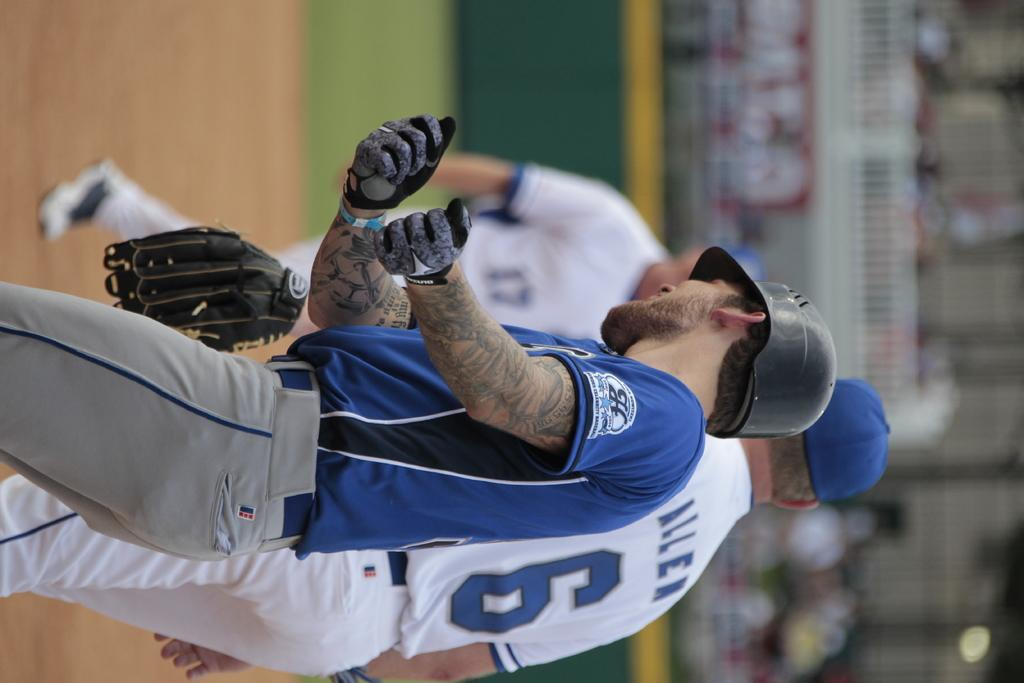How many people are present in the image? There are three people standing in the image. Can you describe any specific clothing or accessories worn by one of the individuals? One of the men is wearing a glove. What can be observed about the background of the image? The background appears blurry. What type of trail can be seen in the background of the image? There is no trail visible in the image; the background appears blurry. 